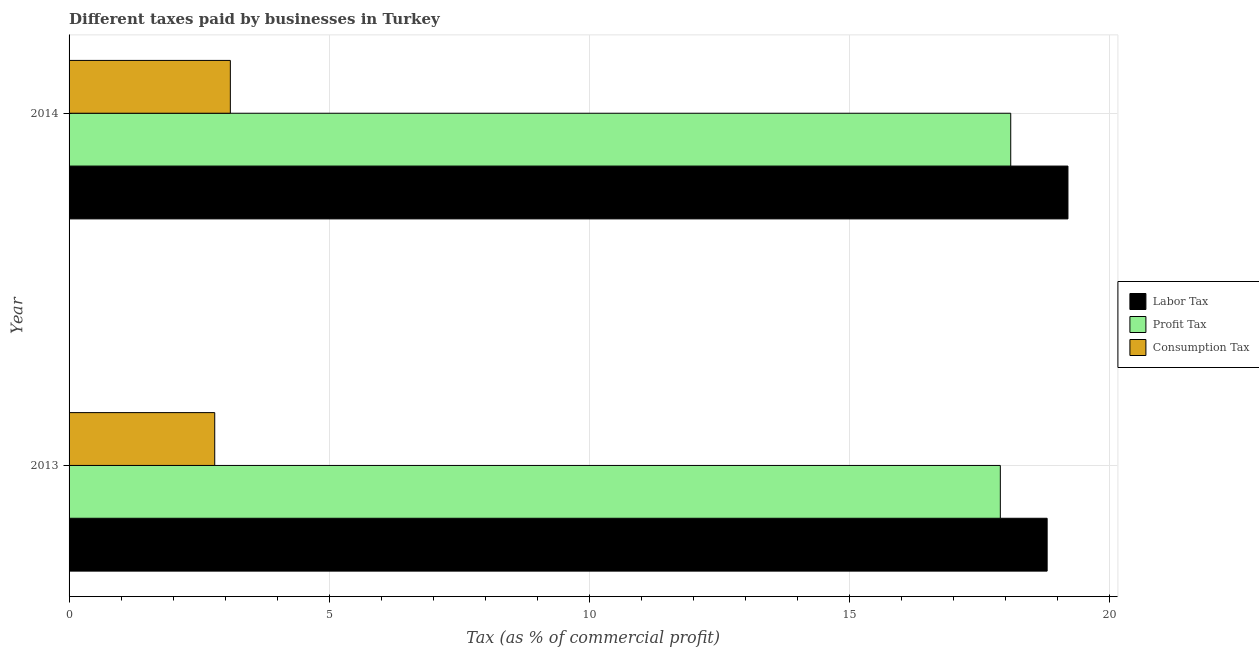How many bars are there on the 1st tick from the bottom?
Your response must be concise. 3. What is the label of the 1st group of bars from the top?
Ensure brevity in your answer.  2014. Across all years, what is the minimum percentage of consumption tax?
Keep it short and to the point. 2.8. In which year was the percentage of profit tax minimum?
Offer a terse response. 2013. What is the difference between the percentage of profit tax in 2013 and that in 2014?
Your response must be concise. -0.2. What is the difference between the percentage of consumption tax in 2013 and the percentage of profit tax in 2014?
Your answer should be compact. -15.3. What is the average percentage of consumption tax per year?
Provide a short and direct response. 2.95. In the year 2014, what is the difference between the percentage of consumption tax and percentage of profit tax?
Your answer should be very brief. -15. In how many years, is the percentage of profit tax greater than 19 %?
Provide a short and direct response. 0. What is the ratio of the percentage of consumption tax in 2013 to that in 2014?
Keep it short and to the point. 0.9. Is the percentage of consumption tax in 2013 less than that in 2014?
Your response must be concise. Yes. Is the difference between the percentage of labor tax in 2013 and 2014 greater than the difference between the percentage of profit tax in 2013 and 2014?
Offer a very short reply. No. In how many years, is the percentage of labor tax greater than the average percentage of labor tax taken over all years?
Offer a terse response. 1. What does the 3rd bar from the top in 2014 represents?
Keep it short and to the point. Labor Tax. What does the 3rd bar from the bottom in 2013 represents?
Your answer should be compact. Consumption Tax. Are all the bars in the graph horizontal?
Your answer should be very brief. Yes. How many years are there in the graph?
Offer a very short reply. 2. What is the difference between two consecutive major ticks on the X-axis?
Your answer should be compact. 5. Does the graph contain any zero values?
Make the answer very short. No. Where does the legend appear in the graph?
Provide a succinct answer. Center right. How many legend labels are there?
Keep it short and to the point. 3. How are the legend labels stacked?
Provide a succinct answer. Vertical. What is the title of the graph?
Keep it short and to the point. Different taxes paid by businesses in Turkey. Does "Social Protection" appear as one of the legend labels in the graph?
Provide a succinct answer. No. What is the label or title of the X-axis?
Offer a very short reply. Tax (as % of commercial profit). What is the label or title of the Y-axis?
Offer a terse response. Year. What is the Tax (as % of commercial profit) of Labor Tax in 2013?
Provide a succinct answer. 18.8. What is the Tax (as % of commercial profit) in Labor Tax in 2014?
Make the answer very short. 19.2. What is the Tax (as % of commercial profit) of Profit Tax in 2014?
Your answer should be very brief. 18.1. What is the Tax (as % of commercial profit) of Consumption Tax in 2014?
Offer a terse response. 3.1. Across all years, what is the maximum Tax (as % of commercial profit) in Labor Tax?
Your response must be concise. 19.2. Across all years, what is the maximum Tax (as % of commercial profit) of Consumption Tax?
Your answer should be very brief. 3.1. Across all years, what is the minimum Tax (as % of commercial profit) in Consumption Tax?
Your answer should be compact. 2.8. What is the difference between the Tax (as % of commercial profit) in Labor Tax in 2013 and that in 2014?
Ensure brevity in your answer.  -0.4. What is the difference between the Tax (as % of commercial profit) of Profit Tax in 2013 and that in 2014?
Keep it short and to the point. -0.2. What is the difference between the Tax (as % of commercial profit) of Labor Tax in 2013 and the Tax (as % of commercial profit) of Profit Tax in 2014?
Make the answer very short. 0.7. What is the difference between the Tax (as % of commercial profit) of Labor Tax in 2013 and the Tax (as % of commercial profit) of Consumption Tax in 2014?
Give a very brief answer. 15.7. What is the average Tax (as % of commercial profit) of Consumption Tax per year?
Provide a short and direct response. 2.95. In the year 2013, what is the difference between the Tax (as % of commercial profit) of Profit Tax and Tax (as % of commercial profit) of Consumption Tax?
Provide a short and direct response. 15.1. In the year 2014, what is the difference between the Tax (as % of commercial profit) in Labor Tax and Tax (as % of commercial profit) in Consumption Tax?
Your response must be concise. 16.1. In the year 2014, what is the difference between the Tax (as % of commercial profit) in Profit Tax and Tax (as % of commercial profit) in Consumption Tax?
Provide a short and direct response. 15. What is the ratio of the Tax (as % of commercial profit) of Labor Tax in 2013 to that in 2014?
Provide a succinct answer. 0.98. What is the ratio of the Tax (as % of commercial profit) in Consumption Tax in 2013 to that in 2014?
Offer a very short reply. 0.9. What is the difference between the highest and the second highest Tax (as % of commercial profit) in Labor Tax?
Make the answer very short. 0.4. What is the difference between the highest and the second highest Tax (as % of commercial profit) in Profit Tax?
Ensure brevity in your answer.  0.2. What is the difference between the highest and the second highest Tax (as % of commercial profit) of Consumption Tax?
Your response must be concise. 0.3. What is the difference between the highest and the lowest Tax (as % of commercial profit) in Profit Tax?
Your answer should be compact. 0.2. What is the difference between the highest and the lowest Tax (as % of commercial profit) of Consumption Tax?
Ensure brevity in your answer.  0.3. 